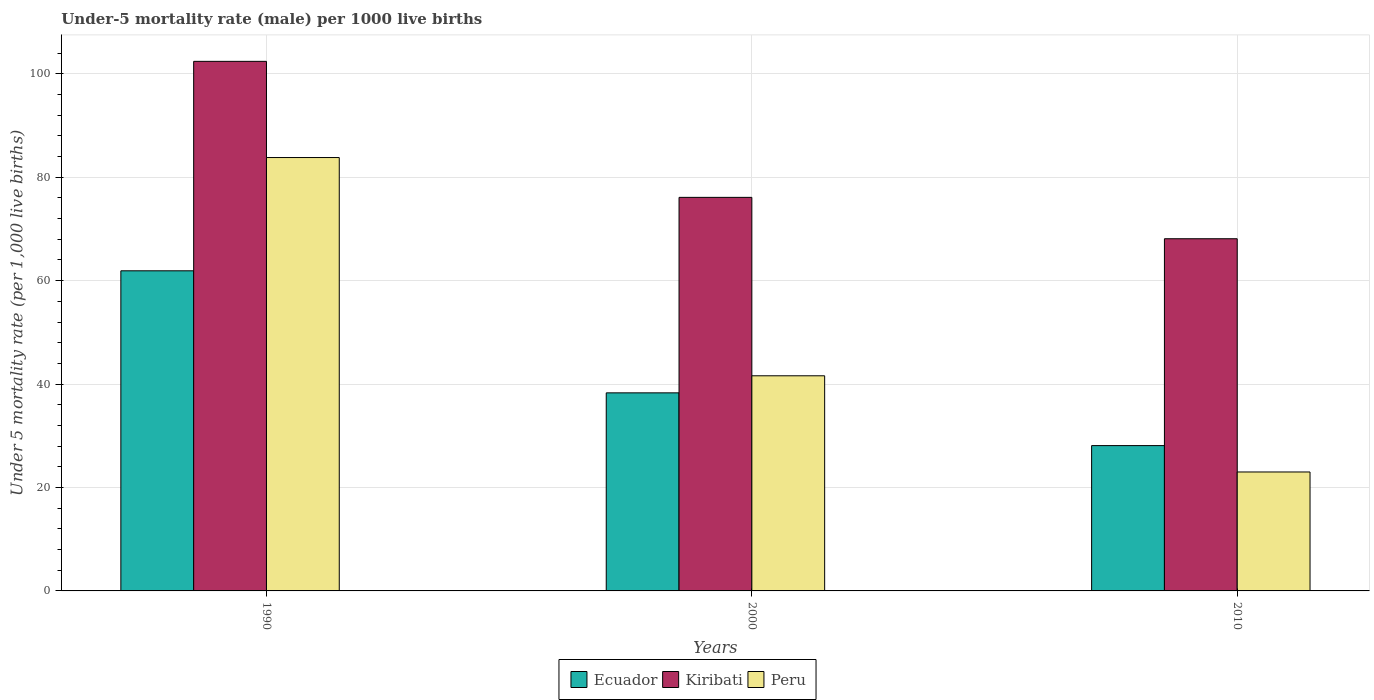Are the number of bars per tick equal to the number of legend labels?
Provide a short and direct response. Yes. How many bars are there on the 1st tick from the left?
Offer a terse response. 3. What is the label of the 3rd group of bars from the left?
Provide a short and direct response. 2010. What is the under-five mortality rate in Peru in 1990?
Your answer should be very brief. 83.8. Across all years, what is the maximum under-five mortality rate in Ecuador?
Offer a very short reply. 61.9. Across all years, what is the minimum under-five mortality rate in Kiribati?
Keep it short and to the point. 68.1. What is the total under-five mortality rate in Kiribati in the graph?
Offer a terse response. 246.6. What is the difference between the under-five mortality rate in Kiribati in 1990 and that in 2000?
Ensure brevity in your answer.  26.3. What is the difference between the under-five mortality rate in Ecuador in 2000 and the under-five mortality rate in Peru in 2010?
Your response must be concise. 15.3. What is the average under-five mortality rate in Peru per year?
Your answer should be very brief. 49.47. In the year 2000, what is the difference between the under-five mortality rate in Ecuador and under-five mortality rate in Peru?
Your response must be concise. -3.3. In how many years, is the under-five mortality rate in Peru greater than 68?
Your answer should be very brief. 1. What is the ratio of the under-five mortality rate in Ecuador in 2000 to that in 2010?
Provide a short and direct response. 1.36. Is the under-five mortality rate in Kiribati in 1990 less than that in 2010?
Your answer should be very brief. No. What is the difference between the highest and the second highest under-five mortality rate in Peru?
Provide a short and direct response. 42.2. What is the difference between the highest and the lowest under-five mortality rate in Kiribati?
Provide a succinct answer. 34.3. In how many years, is the under-five mortality rate in Peru greater than the average under-five mortality rate in Peru taken over all years?
Make the answer very short. 1. What does the 1st bar from the left in 2000 represents?
Ensure brevity in your answer.  Ecuador. What does the 2nd bar from the right in 1990 represents?
Provide a succinct answer. Kiribati. Are all the bars in the graph horizontal?
Your answer should be very brief. No. Are the values on the major ticks of Y-axis written in scientific E-notation?
Ensure brevity in your answer.  No. Does the graph contain any zero values?
Provide a short and direct response. No. Does the graph contain grids?
Your response must be concise. Yes. Where does the legend appear in the graph?
Offer a terse response. Bottom center. How many legend labels are there?
Your response must be concise. 3. What is the title of the graph?
Your answer should be very brief. Under-5 mortality rate (male) per 1000 live births. What is the label or title of the X-axis?
Your response must be concise. Years. What is the label or title of the Y-axis?
Ensure brevity in your answer.  Under 5 mortality rate (per 1,0 live births). What is the Under 5 mortality rate (per 1,000 live births) in Ecuador in 1990?
Provide a succinct answer. 61.9. What is the Under 5 mortality rate (per 1,000 live births) in Kiribati in 1990?
Your answer should be compact. 102.4. What is the Under 5 mortality rate (per 1,000 live births) of Peru in 1990?
Ensure brevity in your answer.  83.8. What is the Under 5 mortality rate (per 1,000 live births) in Ecuador in 2000?
Your answer should be compact. 38.3. What is the Under 5 mortality rate (per 1,000 live births) of Kiribati in 2000?
Provide a short and direct response. 76.1. What is the Under 5 mortality rate (per 1,000 live births) of Peru in 2000?
Make the answer very short. 41.6. What is the Under 5 mortality rate (per 1,000 live births) of Ecuador in 2010?
Ensure brevity in your answer.  28.1. What is the Under 5 mortality rate (per 1,000 live births) of Kiribati in 2010?
Your answer should be very brief. 68.1. What is the Under 5 mortality rate (per 1,000 live births) in Peru in 2010?
Make the answer very short. 23. Across all years, what is the maximum Under 5 mortality rate (per 1,000 live births) in Ecuador?
Your answer should be compact. 61.9. Across all years, what is the maximum Under 5 mortality rate (per 1,000 live births) in Kiribati?
Offer a very short reply. 102.4. Across all years, what is the maximum Under 5 mortality rate (per 1,000 live births) in Peru?
Offer a terse response. 83.8. Across all years, what is the minimum Under 5 mortality rate (per 1,000 live births) of Ecuador?
Offer a terse response. 28.1. Across all years, what is the minimum Under 5 mortality rate (per 1,000 live births) of Kiribati?
Keep it short and to the point. 68.1. Across all years, what is the minimum Under 5 mortality rate (per 1,000 live births) of Peru?
Offer a very short reply. 23. What is the total Under 5 mortality rate (per 1,000 live births) of Ecuador in the graph?
Keep it short and to the point. 128.3. What is the total Under 5 mortality rate (per 1,000 live births) of Kiribati in the graph?
Offer a terse response. 246.6. What is the total Under 5 mortality rate (per 1,000 live births) in Peru in the graph?
Your answer should be compact. 148.4. What is the difference between the Under 5 mortality rate (per 1,000 live births) in Ecuador in 1990 and that in 2000?
Ensure brevity in your answer.  23.6. What is the difference between the Under 5 mortality rate (per 1,000 live births) in Kiribati in 1990 and that in 2000?
Offer a very short reply. 26.3. What is the difference between the Under 5 mortality rate (per 1,000 live births) in Peru in 1990 and that in 2000?
Offer a very short reply. 42.2. What is the difference between the Under 5 mortality rate (per 1,000 live births) in Ecuador in 1990 and that in 2010?
Provide a succinct answer. 33.8. What is the difference between the Under 5 mortality rate (per 1,000 live births) of Kiribati in 1990 and that in 2010?
Keep it short and to the point. 34.3. What is the difference between the Under 5 mortality rate (per 1,000 live births) of Peru in 1990 and that in 2010?
Your answer should be compact. 60.8. What is the difference between the Under 5 mortality rate (per 1,000 live births) in Ecuador in 2000 and that in 2010?
Your answer should be compact. 10.2. What is the difference between the Under 5 mortality rate (per 1,000 live births) of Kiribati in 2000 and that in 2010?
Give a very brief answer. 8. What is the difference between the Under 5 mortality rate (per 1,000 live births) of Ecuador in 1990 and the Under 5 mortality rate (per 1,000 live births) of Peru in 2000?
Provide a short and direct response. 20.3. What is the difference between the Under 5 mortality rate (per 1,000 live births) of Kiribati in 1990 and the Under 5 mortality rate (per 1,000 live births) of Peru in 2000?
Make the answer very short. 60.8. What is the difference between the Under 5 mortality rate (per 1,000 live births) of Ecuador in 1990 and the Under 5 mortality rate (per 1,000 live births) of Kiribati in 2010?
Offer a terse response. -6.2. What is the difference between the Under 5 mortality rate (per 1,000 live births) of Ecuador in 1990 and the Under 5 mortality rate (per 1,000 live births) of Peru in 2010?
Keep it short and to the point. 38.9. What is the difference between the Under 5 mortality rate (per 1,000 live births) in Kiribati in 1990 and the Under 5 mortality rate (per 1,000 live births) in Peru in 2010?
Your answer should be very brief. 79.4. What is the difference between the Under 5 mortality rate (per 1,000 live births) in Ecuador in 2000 and the Under 5 mortality rate (per 1,000 live births) in Kiribati in 2010?
Your answer should be very brief. -29.8. What is the difference between the Under 5 mortality rate (per 1,000 live births) in Kiribati in 2000 and the Under 5 mortality rate (per 1,000 live births) in Peru in 2010?
Give a very brief answer. 53.1. What is the average Under 5 mortality rate (per 1,000 live births) of Ecuador per year?
Provide a short and direct response. 42.77. What is the average Under 5 mortality rate (per 1,000 live births) in Kiribati per year?
Your answer should be compact. 82.2. What is the average Under 5 mortality rate (per 1,000 live births) in Peru per year?
Provide a succinct answer. 49.47. In the year 1990, what is the difference between the Under 5 mortality rate (per 1,000 live births) of Ecuador and Under 5 mortality rate (per 1,000 live births) of Kiribati?
Give a very brief answer. -40.5. In the year 1990, what is the difference between the Under 5 mortality rate (per 1,000 live births) in Ecuador and Under 5 mortality rate (per 1,000 live births) in Peru?
Provide a succinct answer. -21.9. In the year 1990, what is the difference between the Under 5 mortality rate (per 1,000 live births) in Kiribati and Under 5 mortality rate (per 1,000 live births) in Peru?
Your answer should be compact. 18.6. In the year 2000, what is the difference between the Under 5 mortality rate (per 1,000 live births) in Ecuador and Under 5 mortality rate (per 1,000 live births) in Kiribati?
Provide a succinct answer. -37.8. In the year 2000, what is the difference between the Under 5 mortality rate (per 1,000 live births) of Ecuador and Under 5 mortality rate (per 1,000 live births) of Peru?
Give a very brief answer. -3.3. In the year 2000, what is the difference between the Under 5 mortality rate (per 1,000 live births) in Kiribati and Under 5 mortality rate (per 1,000 live births) in Peru?
Your answer should be compact. 34.5. In the year 2010, what is the difference between the Under 5 mortality rate (per 1,000 live births) in Ecuador and Under 5 mortality rate (per 1,000 live births) in Kiribati?
Keep it short and to the point. -40. In the year 2010, what is the difference between the Under 5 mortality rate (per 1,000 live births) in Ecuador and Under 5 mortality rate (per 1,000 live births) in Peru?
Keep it short and to the point. 5.1. In the year 2010, what is the difference between the Under 5 mortality rate (per 1,000 live births) in Kiribati and Under 5 mortality rate (per 1,000 live births) in Peru?
Offer a very short reply. 45.1. What is the ratio of the Under 5 mortality rate (per 1,000 live births) of Ecuador in 1990 to that in 2000?
Give a very brief answer. 1.62. What is the ratio of the Under 5 mortality rate (per 1,000 live births) in Kiribati in 1990 to that in 2000?
Keep it short and to the point. 1.35. What is the ratio of the Under 5 mortality rate (per 1,000 live births) of Peru in 1990 to that in 2000?
Ensure brevity in your answer.  2.01. What is the ratio of the Under 5 mortality rate (per 1,000 live births) of Ecuador in 1990 to that in 2010?
Offer a terse response. 2.2. What is the ratio of the Under 5 mortality rate (per 1,000 live births) of Kiribati in 1990 to that in 2010?
Keep it short and to the point. 1.5. What is the ratio of the Under 5 mortality rate (per 1,000 live births) of Peru in 1990 to that in 2010?
Keep it short and to the point. 3.64. What is the ratio of the Under 5 mortality rate (per 1,000 live births) in Ecuador in 2000 to that in 2010?
Provide a succinct answer. 1.36. What is the ratio of the Under 5 mortality rate (per 1,000 live births) of Kiribati in 2000 to that in 2010?
Your response must be concise. 1.12. What is the ratio of the Under 5 mortality rate (per 1,000 live births) of Peru in 2000 to that in 2010?
Offer a very short reply. 1.81. What is the difference between the highest and the second highest Under 5 mortality rate (per 1,000 live births) in Ecuador?
Your answer should be very brief. 23.6. What is the difference between the highest and the second highest Under 5 mortality rate (per 1,000 live births) of Kiribati?
Your answer should be very brief. 26.3. What is the difference between the highest and the second highest Under 5 mortality rate (per 1,000 live births) in Peru?
Make the answer very short. 42.2. What is the difference between the highest and the lowest Under 5 mortality rate (per 1,000 live births) in Ecuador?
Your answer should be compact. 33.8. What is the difference between the highest and the lowest Under 5 mortality rate (per 1,000 live births) of Kiribati?
Your answer should be compact. 34.3. What is the difference between the highest and the lowest Under 5 mortality rate (per 1,000 live births) of Peru?
Keep it short and to the point. 60.8. 